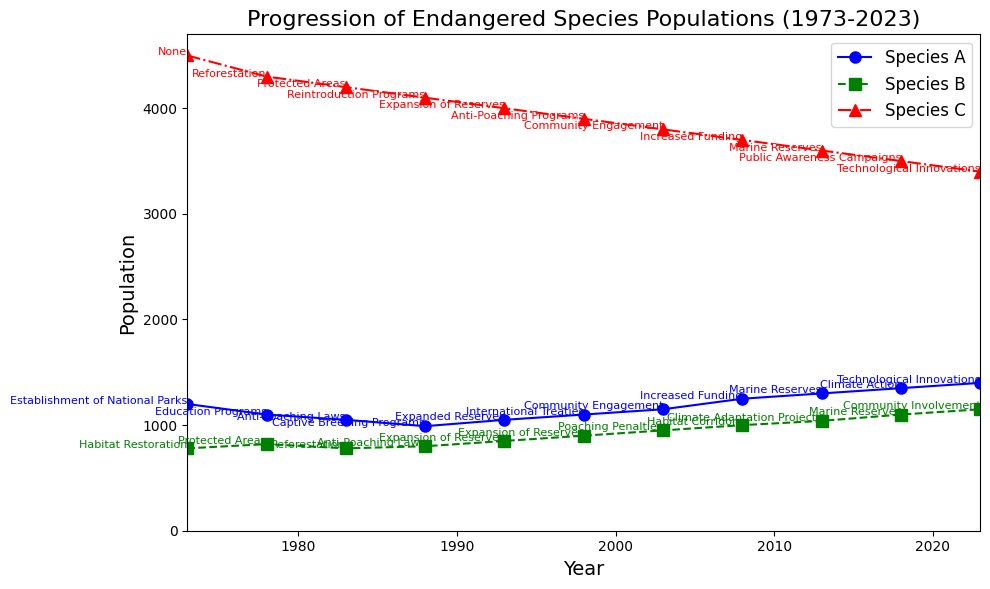What year did Species A reach its lowest population, and what was the population count? To find the lowest population for Species A, look for the smallest y-coordinate of the blue line in the figure. The lowest point is 990 in the year 1988.
Answer: 1988, 990 Between Species B and Species C, which species had a higher population in 2013, and by how much? In 2013, compare the green line (Species B) and the red line (Species C). Species B had a population of 1040, while Species C had 3600. The population difference is 3600 - 1040 = 2560.
Answer: Species C, 2560 In which year did Species A first surpass a population of 1300? Observe the blue line for Species A and find when it first exceeds the y-coordinate of 1300. Species A reaches 1350 in 2018.
Answer: 2018 Which species showed the most consistent population growth over the 50 years? Examine the trends in each line. The species with the least fluctuation and steady increase or decrease is Species B, represented by the green line.
Answer: Species B What is the average population of Species C over the 50 years? Add the population values for Species C across all years (4500 + 4300 + 4200 + 4100 + 4000 + 3900 + 3800 + 3700 + 3600 + 3500 + 3400 = 42500) and divide by the number of data points (11). The average is 42500 / 11 = 3863.64.
Answer: 3863.64 When did the anti-poaching laws first come into effect for Species A, and what was its population at that time? Look for the text labels indicating conservation efforts for Species A. Anti-poaching laws are mentioned in 1983, and the population at that time was 1050.
Answer: 1983, 1050 Compare the population trends of Species B and Species C from 1993 to 2023 in terms of growth and decline. Species B (green line) showed an overall increase from 850 to 1150, while Species C (red line) showed a steady decline from 4000 to 3400. Species B grew by 300, and Species C declined by 600.
Answer: Species B: growth, 300; Species C: decline, 600 Which conservation effort is associated with the highest population count of Species A? Identify the highest point of the blue line, which is 1400 in 2023, and look at the conservation effort text near that point. The associated conservation effort is Technological Innovations.
Answer: Technological Innovations Was there any year when all three species showed a simultaneous increase in population compared to the previous data point? Check the lines for all three species between each consecutive year. In 1993, all three species (Species A: 1050 to 1100, Species B: 820 to 850, Species C: 4100 to 4000) had an increase.
Answer: No 